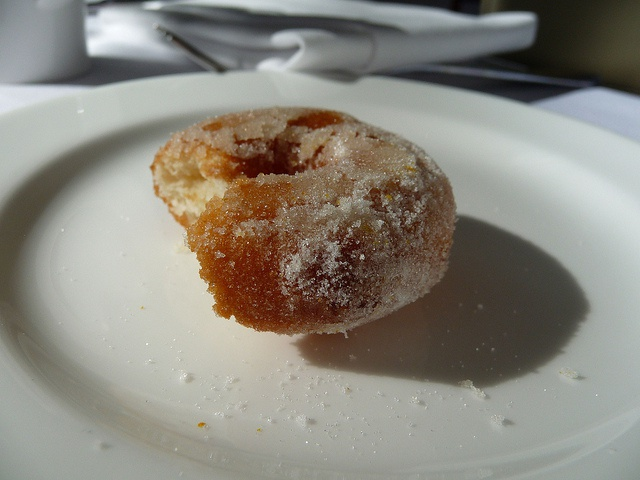Describe the objects in this image and their specific colors. I can see a donut in gray and maroon tones in this image. 